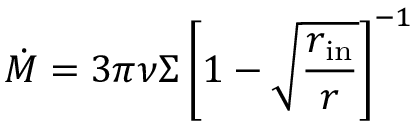<formula> <loc_0><loc_0><loc_500><loc_500>{ \dot { M } } = 3 \pi \nu \Sigma \left [ 1 - { \sqrt { \frac { r _ { i n } } { r } } } \right ] ^ { - 1 }</formula> 